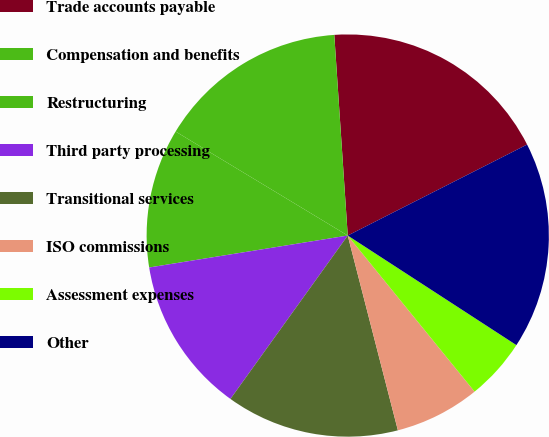Convert chart to OTSL. <chart><loc_0><loc_0><loc_500><loc_500><pie_chart><fcel>Trade accounts payable<fcel>Compensation and benefits<fcel>Restructuring<fcel>Third party processing<fcel>Transitional services<fcel>ISO commissions<fcel>Assessment expenses<fcel>Other<nl><fcel>18.59%<fcel>15.28%<fcel>11.19%<fcel>12.55%<fcel>13.92%<fcel>6.85%<fcel>4.97%<fcel>16.64%<nl></chart> 